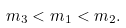<formula> <loc_0><loc_0><loc_500><loc_500>m _ { 3 } < m _ { 1 } < m _ { 2 } .</formula> 